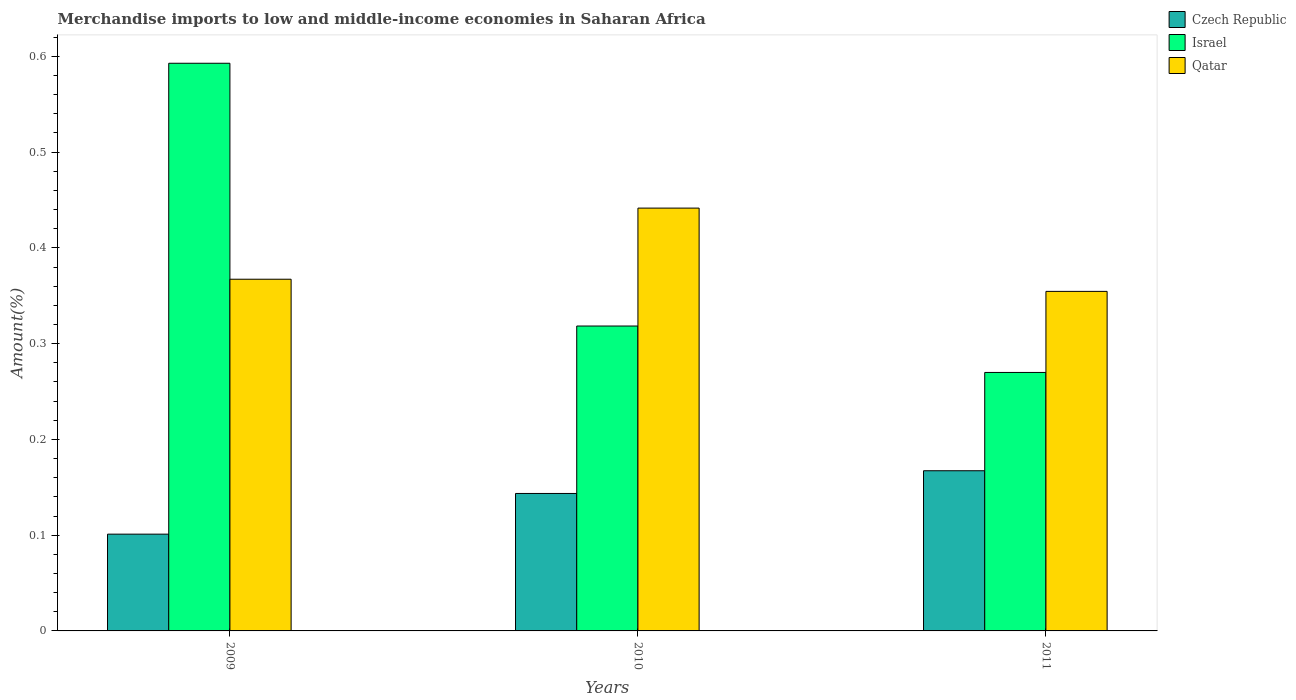Are the number of bars per tick equal to the number of legend labels?
Your answer should be very brief. Yes. What is the label of the 2nd group of bars from the left?
Offer a terse response. 2010. In how many cases, is the number of bars for a given year not equal to the number of legend labels?
Offer a terse response. 0. What is the percentage of amount earned from merchandise imports in Qatar in 2009?
Provide a succinct answer. 0.37. Across all years, what is the maximum percentage of amount earned from merchandise imports in Qatar?
Your answer should be compact. 0.44. Across all years, what is the minimum percentage of amount earned from merchandise imports in Israel?
Ensure brevity in your answer.  0.27. In which year was the percentage of amount earned from merchandise imports in Czech Republic maximum?
Ensure brevity in your answer.  2011. In which year was the percentage of amount earned from merchandise imports in Czech Republic minimum?
Offer a very short reply. 2009. What is the total percentage of amount earned from merchandise imports in Qatar in the graph?
Keep it short and to the point. 1.16. What is the difference between the percentage of amount earned from merchandise imports in Czech Republic in 2009 and that in 2011?
Your answer should be very brief. -0.07. What is the difference between the percentage of amount earned from merchandise imports in Israel in 2011 and the percentage of amount earned from merchandise imports in Qatar in 2009?
Offer a terse response. -0.1. What is the average percentage of amount earned from merchandise imports in Qatar per year?
Offer a terse response. 0.39. In the year 2010, what is the difference between the percentage of amount earned from merchandise imports in Qatar and percentage of amount earned from merchandise imports in Israel?
Make the answer very short. 0.12. What is the ratio of the percentage of amount earned from merchandise imports in Qatar in 2010 to that in 2011?
Ensure brevity in your answer.  1.25. What is the difference between the highest and the second highest percentage of amount earned from merchandise imports in Czech Republic?
Provide a short and direct response. 0.02. What is the difference between the highest and the lowest percentage of amount earned from merchandise imports in Qatar?
Provide a short and direct response. 0.09. Is the sum of the percentage of amount earned from merchandise imports in Israel in 2010 and 2011 greater than the maximum percentage of amount earned from merchandise imports in Qatar across all years?
Provide a succinct answer. Yes. What does the 3rd bar from the left in 2011 represents?
Your answer should be very brief. Qatar. Are all the bars in the graph horizontal?
Ensure brevity in your answer.  No. Are the values on the major ticks of Y-axis written in scientific E-notation?
Your answer should be compact. No. Does the graph contain any zero values?
Your answer should be very brief. No. What is the title of the graph?
Your answer should be compact. Merchandise imports to low and middle-income economies in Saharan Africa. What is the label or title of the Y-axis?
Offer a very short reply. Amount(%). What is the Amount(%) of Czech Republic in 2009?
Your answer should be compact. 0.1. What is the Amount(%) in Israel in 2009?
Provide a short and direct response. 0.59. What is the Amount(%) in Qatar in 2009?
Your answer should be very brief. 0.37. What is the Amount(%) in Czech Republic in 2010?
Offer a terse response. 0.14. What is the Amount(%) of Israel in 2010?
Offer a very short reply. 0.32. What is the Amount(%) in Qatar in 2010?
Provide a short and direct response. 0.44. What is the Amount(%) of Czech Republic in 2011?
Your response must be concise. 0.17. What is the Amount(%) of Israel in 2011?
Provide a succinct answer. 0.27. What is the Amount(%) of Qatar in 2011?
Give a very brief answer. 0.35. Across all years, what is the maximum Amount(%) of Czech Republic?
Your response must be concise. 0.17. Across all years, what is the maximum Amount(%) of Israel?
Ensure brevity in your answer.  0.59. Across all years, what is the maximum Amount(%) in Qatar?
Make the answer very short. 0.44. Across all years, what is the minimum Amount(%) in Czech Republic?
Offer a very short reply. 0.1. Across all years, what is the minimum Amount(%) in Israel?
Your answer should be very brief. 0.27. Across all years, what is the minimum Amount(%) in Qatar?
Your response must be concise. 0.35. What is the total Amount(%) of Czech Republic in the graph?
Provide a short and direct response. 0.41. What is the total Amount(%) of Israel in the graph?
Your answer should be very brief. 1.18. What is the total Amount(%) of Qatar in the graph?
Offer a very short reply. 1.16. What is the difference between the Amount(%) in Czech Republic in 2009 and that in 2010?
Your answer should be compact. -0.04. What is the difference between the Amount(%) of Israel in 2009 and that in 2010?
Your answer should be very brief. 0.27. What is the difference between the Amount(%) of Qatar in 2009 and that in 2010?
Your answer should be very brief. -0.07. What is the difference between the Amount(%) in Czech Republic in 2009 and that in 2011?
Your response must be concise. -0.07. What is the difference between the Amount(%) of Israel in 2009 and that in 2011?
Your response must be concise. 0.32. What is the difference between the Amount(%) in Qatar in 2009 and that in 2011?
Offer a terse response. 0.01. What is the difference between the Amount(%) of Czech Republic in 2010 and that in 2011?
Your answer should be very brief. -0.02. What is the difference between the Amount(%) in Israel in 2010 and that in 2011?
Your response must be concise. 0.05. What is the difference between the Amount(%) of Qatar in 2010 and that in 2011?
Ensure brevity in your answer.  0.09. What is the difference between the Amount(%) of Czech Republic in 2009 and the Amount(%) of Israel in 2010?
Make the answer very short. -0.22. What is the difference between the Amount(%) of Czech Republic in 2009 and the Amount(%) of Qatar in 2010?
Offer a very short reply. -0.34. What is the difference between the Amount(%) in Israel in 2009 and the Amount(%) in Qatar in 2010?
Your answer should be compact. 0.15. What is the difference between the Amount(%) in Czech Republic in 2009 and the Amount(%) in Israel in 2011?
Make the answer very short. -0.17. What is the difference between the Amount(%) of Czech Republic in 2009 and the Amount(%) of Qatar in 2011?
Give a very brief answer. -0.25. What is the difference between the Amount(%) in Israel in 2009 and the Amount(%) in Qatar in 2011?
Provide a succinct answer. 0.24. What is the difference between the Amount(%) of Czech Republic in 2010 and the Amount(%) of Israel in 2011?
Make the answer very short. -0.13. What is the difference between the Amount(%) in Czech Republic in 2010 and the Amount(%) in Qatar in 2011?
Your answer should be compact. -0.21. What is the difference between the Amount(%) in Israel in 2010 and the Amount(%) in Qatar in 2011?
Your response must be concise. -0.04. What is the average Amount(%) of Czech Republic per year?
Keep it short and to the point. 0.14. What is the average Amount(%) of Israel per year?
Offer a terse response. 0.39. What is the average Amount(%) in Qatar per year?
Keep it short and to the point. 0.39. In the year 2009, what is the difference between the Amount(%) in Czech Republic and Amount(%) in Israel?
Your answer should be very brief. -0.49. In the year 2009, what is the difference between the Amount(%) of Czech Republic and Amount(%) of Qatar?
Offer a terse response. -0.27. In the year 2009, what is the difference between the Amount(%) in Israel and Amount(%) in Qatar?
Your answer should be very brief. 0.23. In the year 2010, what is the difference between the Amount(%) of Czech Republic and Amount(%) of Israel?
Provide a succinct answer. -0.17. In the year 2010, what is the difference between the Amount(%) of Czech Republic and Amount(%) of Qatar?
Offer a very short reply. -0.3. In the year 2010, what is the difference between the Amount(%) in Israel and Amount(%) in Qatar?
Offer a very short reply. -0.12. In the year 2011, what is the difference between the Amount(%) in Czech Republic and Amount(%) in Israel?
Your response must be concise. -0.1. In the year 2011, what is the difference between the Amount(%) of Czech Republic and Amount(%) of Qatar?
Offer a very short reply. -0.19. In the year 2011, what is the difference between the Amount(%) in Israel and Amount(%) in Qatar?
Give a very brief answer. -0.08. What is the ratio of the Amount(%) of Czech Republic in 2009 to that in 2010?
Provide a short and direct response. 0.7. What is the ratio of the Amount(%) of Israel in 2009 to that in 2010?
Give a very brief answer. 1.86. What is the ratio of the Amount(%) of Qatar in 2009 to that in 2010?
Your response must be concise. 0.83. What is the ratio of the Amount(%) of Czech Republic in 2009 to that in 2011?
Make the answer very short. 0.6. What is the ratio of the Amount(%) in Israel in 2009 to that in 2011?
Provide a succinct answer. 2.2. What is the ratio of the Amount(%) of Qatar in 2009 to that in 2011?
Offer a terse response. 1.04. What is the ratio of the Amount(%) in Czech Republic in 2010 to that in 2011?
Your answer should be very brief. 0.86. What is the ratio of the Amount(%) in Israel in 2010 to that in 2011?
Provide a succinct answer. 1.18. What is the ratio of the Amount(%) of Qatar in 2010 to that in 2011?
Your answer should be very brief. 1.25. What is the difference between the highest and the second highest Amount(%) in Czech Republic?
Make the answer very short. 0.02. What is the difference between the highest and the second highest Amount(%) of Israel?
Provide a succinct answer. 0.27. What is the difference between the highest and the second highest Amount(%) of Qatar?
Your response must be concise. 0.07. What is the difference between the highest and the lowest Amount(%) in Czech Republic?
Offer a very short reply. 0.07. What is the difference between the highest and the lowest Amount(%) of Israel?
Make the answer very short. 0.32. What is the difference between the highest and the lowest Amount(%) in Qatar?
Your response must be concise. 0.09. 